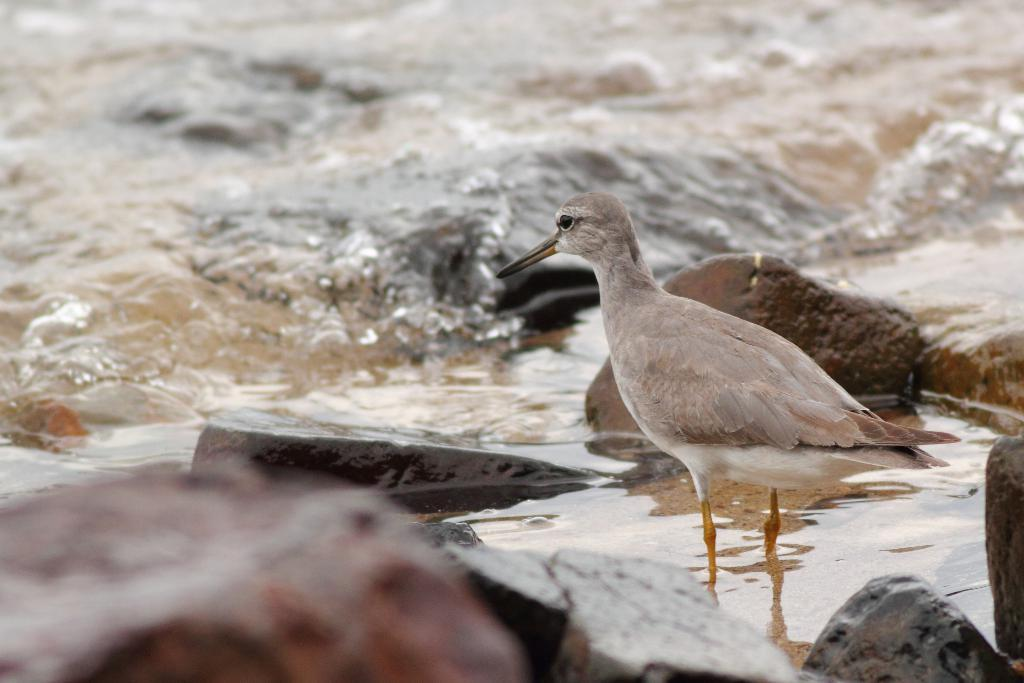What type of animal can be seen in the water on the right side of the image? There is a bird in the water on the right side of the image. What is located near the bird in the water? There are rocks beside the bird. Can you describe the background of the image? The background of the image is blurred. What statement is being made by the bird's leg in the image? There is no statement being made by the bird's leg in the image, as it is a bird and not capable of making statements. 